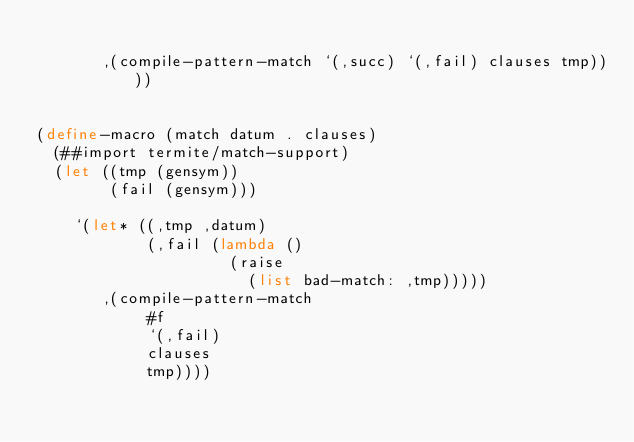Convert code to text. <code><loc_0><loc_0><loc_500><loc_500><_Scheme_>
       ,(compile-pattern-match `(,succ) `(,fail) clauses tmp))))


(define-macro (match datum . clauses)
  (##import termite/match-support)
  (let ((tmp (gensym))
        (fail (gensym)))

    `(let* ((,tmp ,datum)
            (,fail (lambda ()
                     (raise
                       (list bad-match: ,tmp)))))
       ,(compile-pattern-match
            #f
            `(,fail)
            clauses
            tmp))))
</code> 